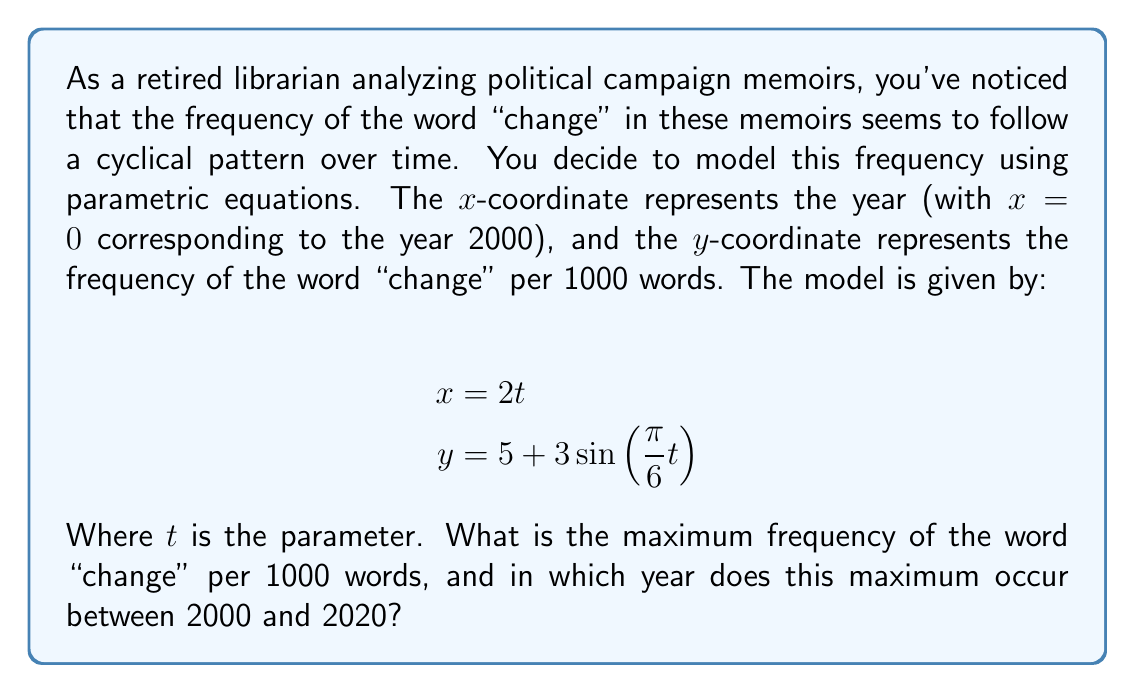Can you answer this question? To solve this problem, we need to follow these steps:

1) First, we need to find the maximum value of y. The sine function oscillates between -1 and 1, so the maximum value occurs when $\sin(\frac{\pi}{6}t) = 1$. Therefore:

   $y_{max} = 5 + 3(1) = 8$

2) To find when this maximum occurs, we need to solve:

   $\sin(\frac{\pi}{6}t) = 1$

3) This occurs when $\frac{\pi}{6}t = \frac{\pi}{2} + 2\pi n$, where n is any integer. Solving for t:

   $t = 3 + 12n$

4) Now, we need to convert this t value to a year. Recall that x = 2t, and x = 0 corresponds to the year 2000. So, the year is given by 2000 + 2t.

5) The first maximum after 2000 occurs when n = 0, so t = 3:

   Year = 2000 + 2(3) = 2006

6) We need to check if this is the only maximum between 2000 and 2020. The next maximum would occur when n = 1, so t = 15:

   Year = 2000 + 2(15) = 2030

   This is outside our range, so 2006 is the only maximum between 2000 and 2020.
Answer: The maximum frequency of the word "change" is 8 per 1000 words, occurring in the year 2006. 